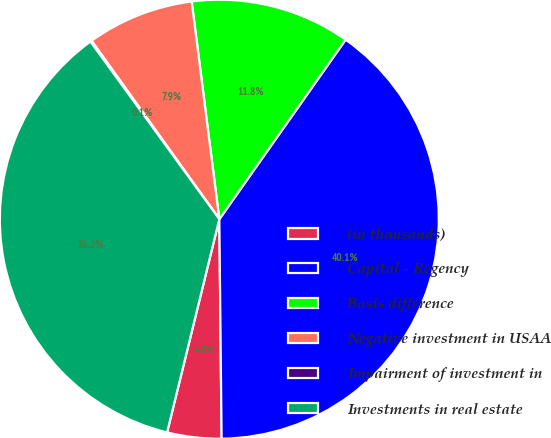Convert chart. <chart><loc_0><loc_0><loc_500><loc_500><pie_chart><fcel>(in thousands)<fcel>Capital - Regency<fcel>Basis difference<fcel>Negative investment in USAA<fcel>Impairment of investment in<fcel>Investments in real estate<nl><fcel>3.99%<fcel>40.08%<fcel>11.77%<fcel>7.88%<fcel>0.1%<fcel>36.19%<nl></chart> 